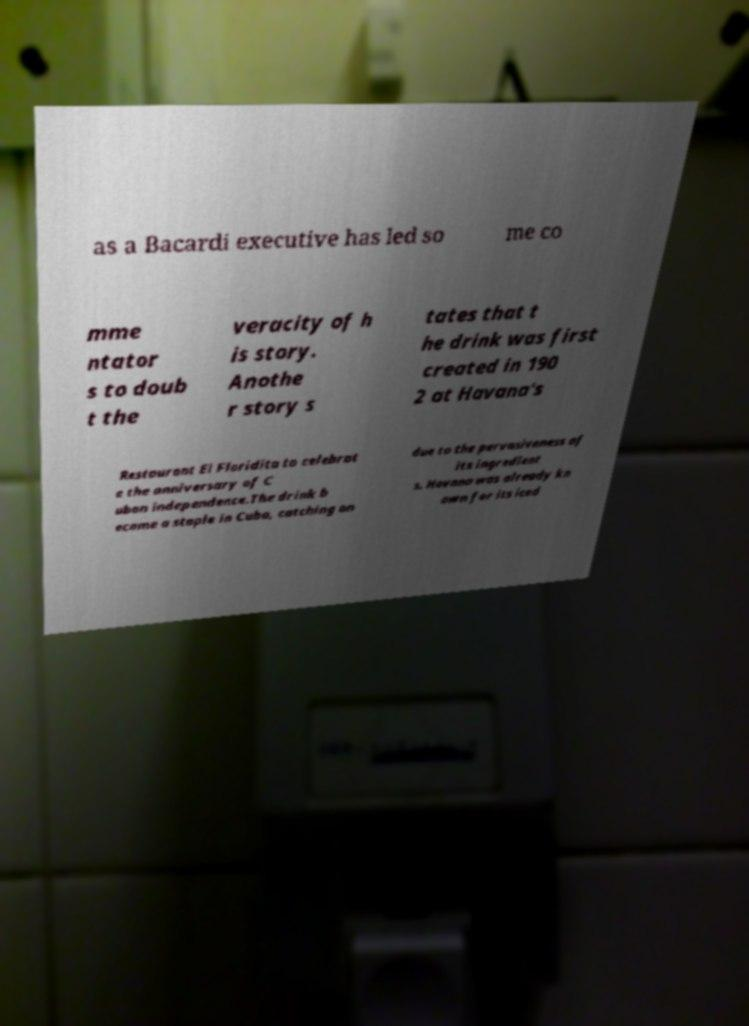Can you read and provide the text displayed in the image?This photo seems to have some interesting text. Can you extract and type it out for me? as a Bacardi executive has led so me co mme ntator s to doub t the veracity of h is story. Anothe r story s tates that t he drink was first created in 190 2 at Havana's Restaurant El Floridita to celebrat e the anniversary of C uban independence.The drink b ecame a staple in Cuba, catching on due to the pervasiveness of its ingredient s. Havana was already kn own for its iced 